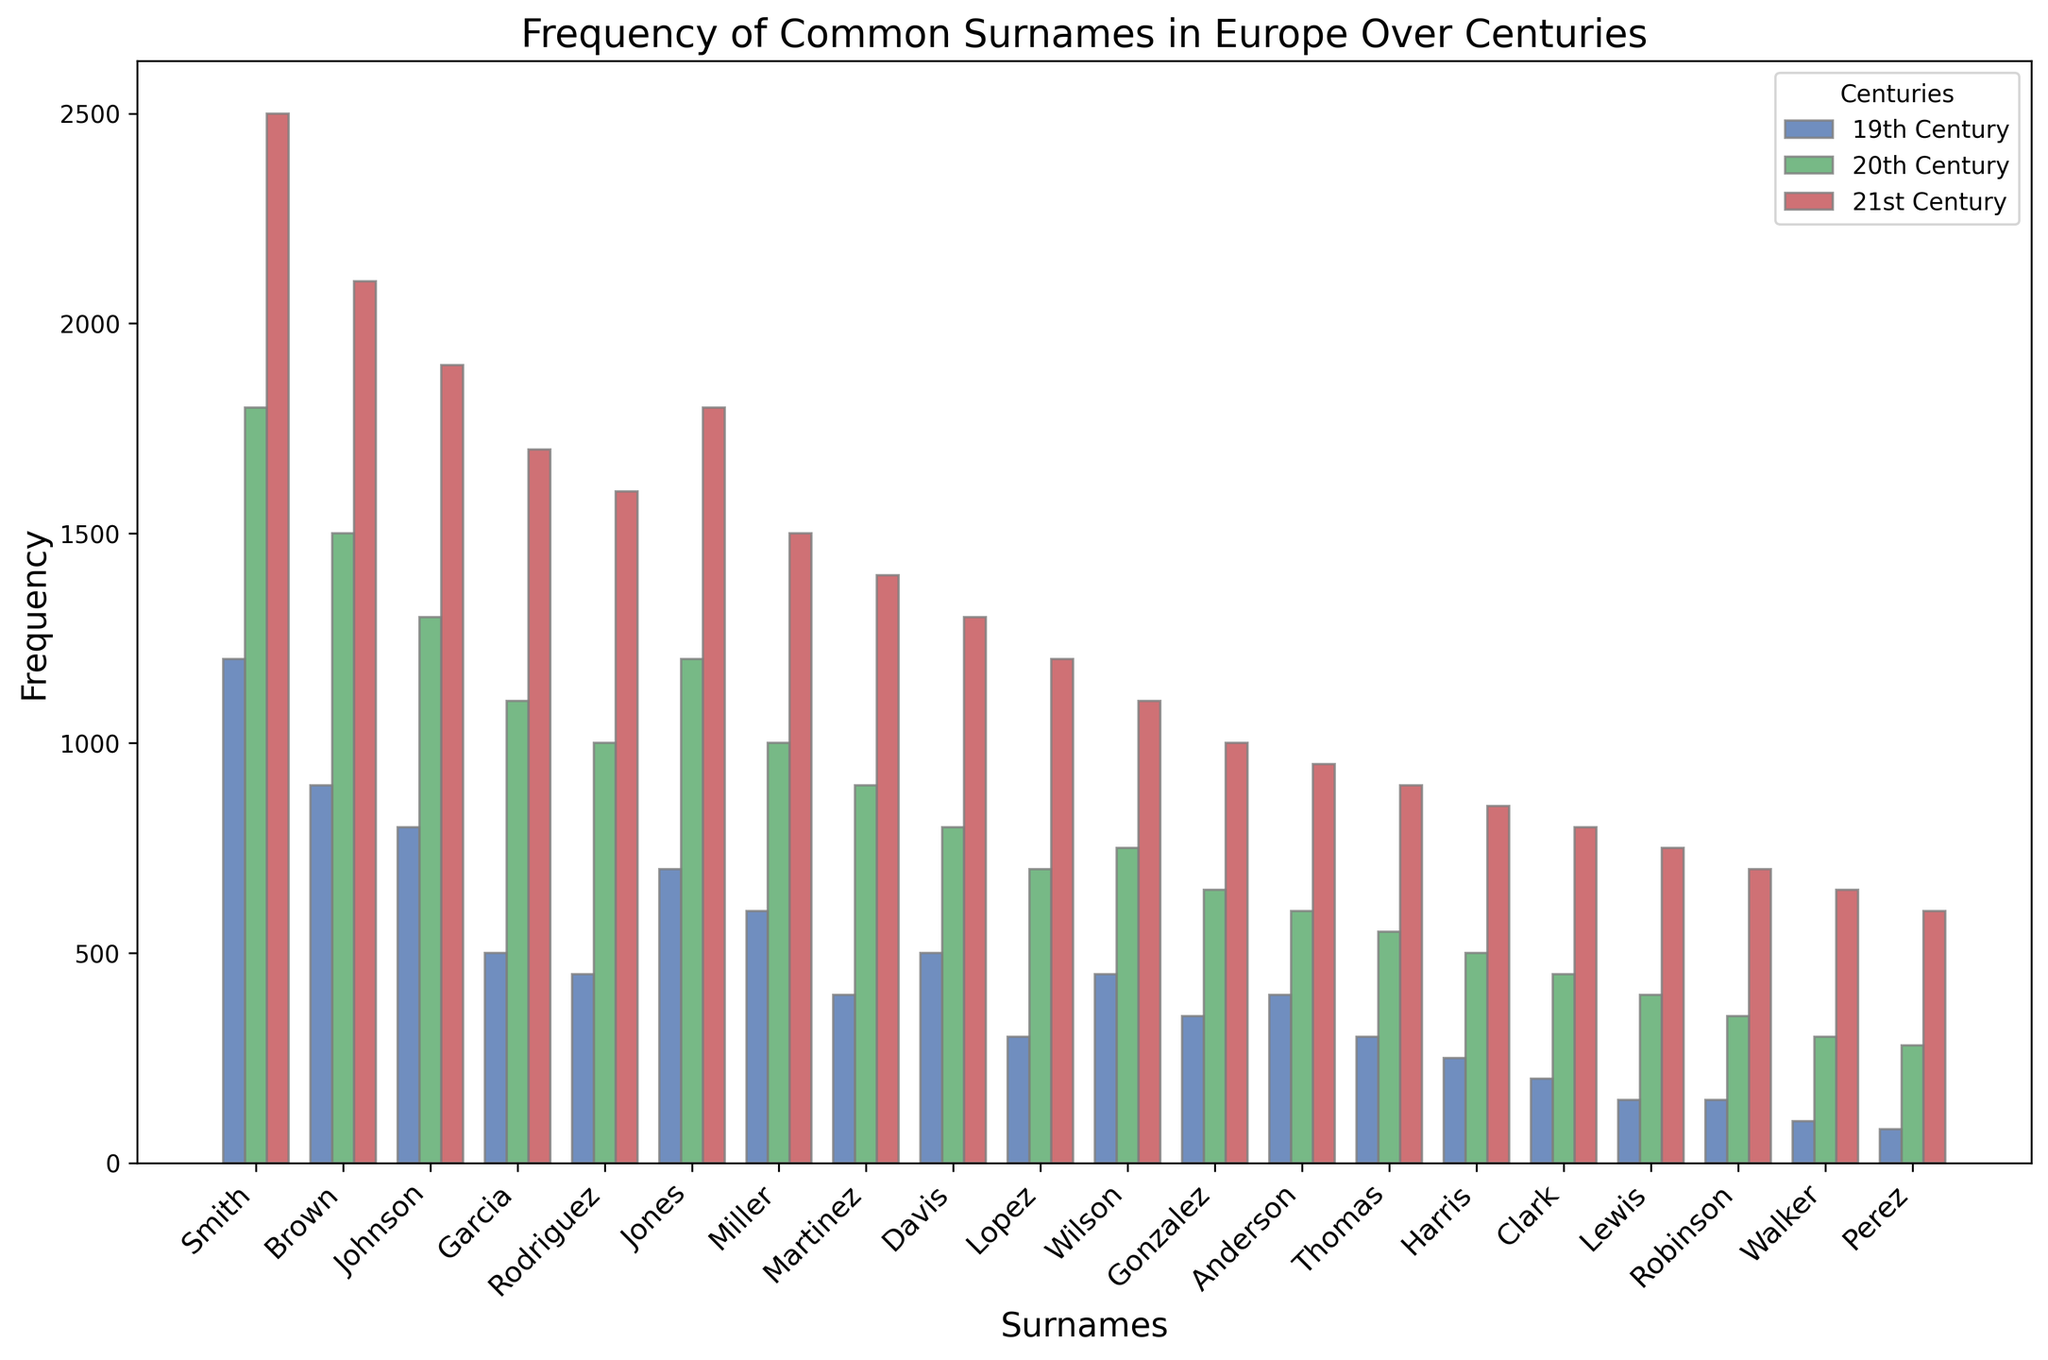What is the most frequent surname in the 21st century? The figure shows the frequency of common surnames over the centuries. To find the most frequent surname in the 21st century, we look for the tallest bar representing this century. Smith has the highest frequency bar in the 21st century with 2500 occurrences.
Answer: Smith Which surname shows the least increase from the 19th to the 20th century? To determine the surname with the least increase, calculate the difference between the 20th century and the 19th century for each surname and find the minimum value. Lewis increased from 150 to 400, giving a difference of 250, which is the smallest.
Answer: Lewis How many surnames had a frequency greater than 1000 in the 19th century? Inspect the bars for the 19th century and count those that surpass the 1000 frequency mark. Smith, Brown, and Johnson are the surnames that exceed this frequency, totaling 3 surnames.
Answer: 3 What is the average frequency of the surname "Garcia" over the three centuries? To compute the average frequency of Garcia, sum the frequencies of the 19th, 20th, and 21st centuries (500 + 1100 + 1700) and divide by 3. The calculation is 3300/3 = 1100.
Answer: 1100 Which surname has the smallest frequency in the 19th century? To identify the surname with the smallest frequency in the 19th century, we look at the shortest bar for this century. Perez has the smallest frequency with 80 occurrences.
Answer: Perez What is the total frequency of the surname "Jones" across all three centuries? Add the frequencies of the surname "Jones" for the 19th, 20th, and 21st centuries. The values are 700, 1200, and 1800, respectively. The total is 700 + 1200 + 1800 = 3700.
Answer: 3700 Which surname has the highest growth rate from the 20th to the 21st century? Calculate the growth rate ((21st Century - 20th Century) / 20th Century) for each surname and identify the highest value. Walker grows from 300 to 650, so its rate is (650 - 300) / 300 ≈ 1.17 or 117%. This is the highest growth among all surnames.
Answer: Walker 